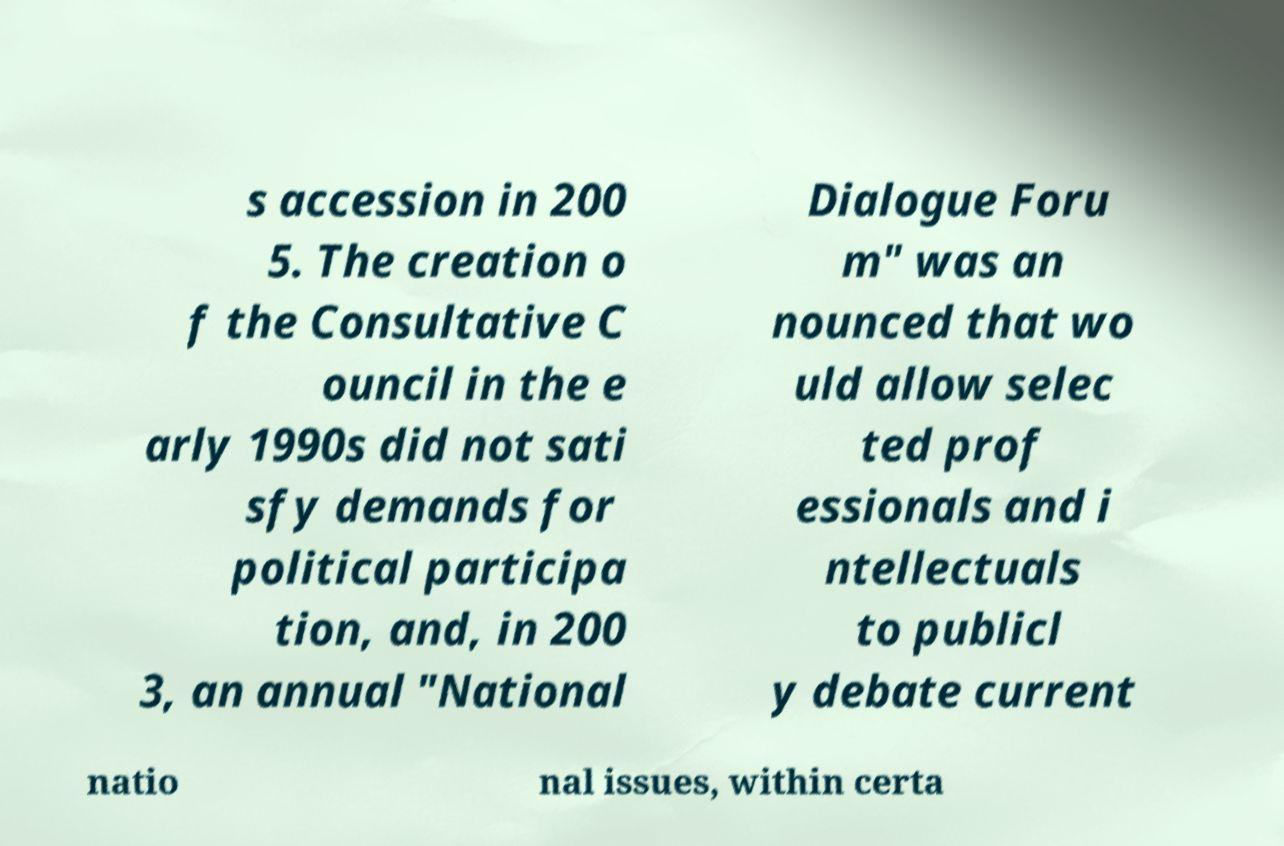For documentation purposes, I need the text within this image transcribed. Could you provide that? s accession in 200 5. The creation o f the Consultative C ouncil in the e arly 1990s did not sati sfy demands for political participa tion, and, in 200 3, an annual "National Dialogue Foru m" was an nounced that wo uld allow selec ted prof essionals and i ntellectuals to publicl y debate current natio nal issues, within certa 